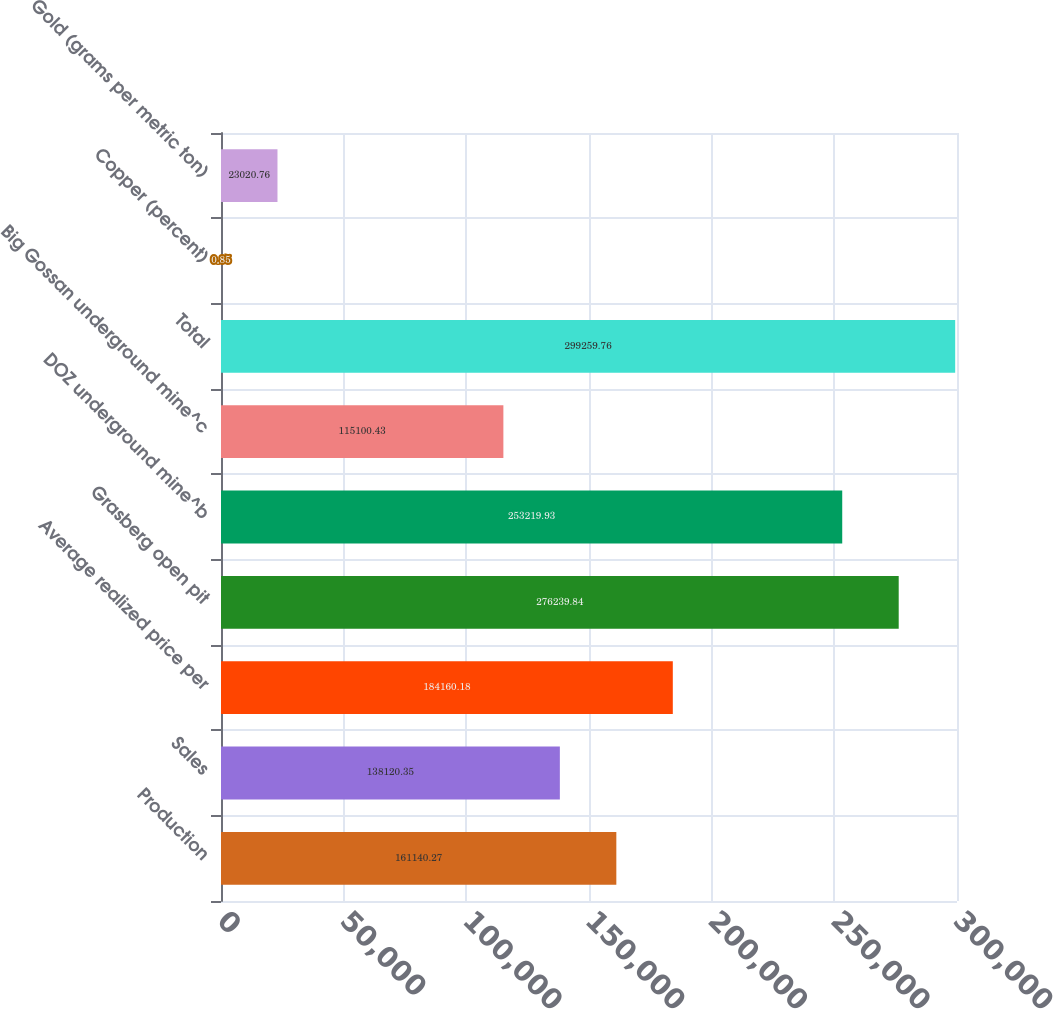<chart> <loc_0><loc_0><loc_500><loc_500><bar_chart><fcel>Production<fcel>Sales<fcel>Average realized price per<fcel>Grasberg open pit<fcel>DOZ underground mine^b<fcel>Big Gossan underground mine^c<fcel>Total<fcel>Copper (percent)<fcel>Gold (grams per metric ton)<nl><fcel>161140<fcel>138120<fcel>184160<fcel>276240<fcel>253220<fcel>115100<fcel>299260<fcel>0.85<fcel>23020.8<nl></chart> 